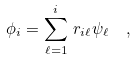Convert formula to latex. <formula><loc_0><loc_0><loc_500><loc_500>\phi _ { i } = \sum _ { \ell = 1 } ^ { i } \, r _ { i \ell } \psi _ { \ell } \ \ ,</formula> 